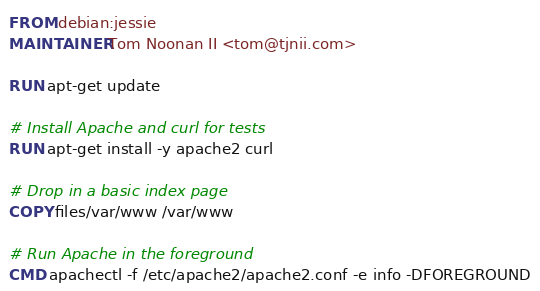<code> <loc_0><loc_0><loc_500><loc_500><_Dockerfile_>FROM debian:jessie
MAINTAINER Tom Noonan II <tom@tjnii.com>

RUN apt-get update

# Install Apache and curl for tests
RUN apt-get install -y apache2 curl

# Drop in a basic index page
COPY files/var/www /var/www

# Run Apache in the foreground
CMD apachectl -f /etc/apache2/apache2.conf -e info -DFOREGROUND
</code> 